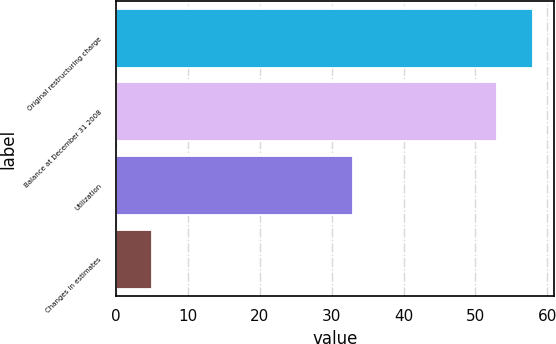<chart> <loc_0><loc_0><loc_500><loc_500><bar_chart><fcel>Original restructuring charge<fcel>Balance at December 31 2008<fcel>Utilization<fcel>Changes in estimates<nl><fcel>58<fcel>53<fcel>33<fcel>5<nl></chart> 